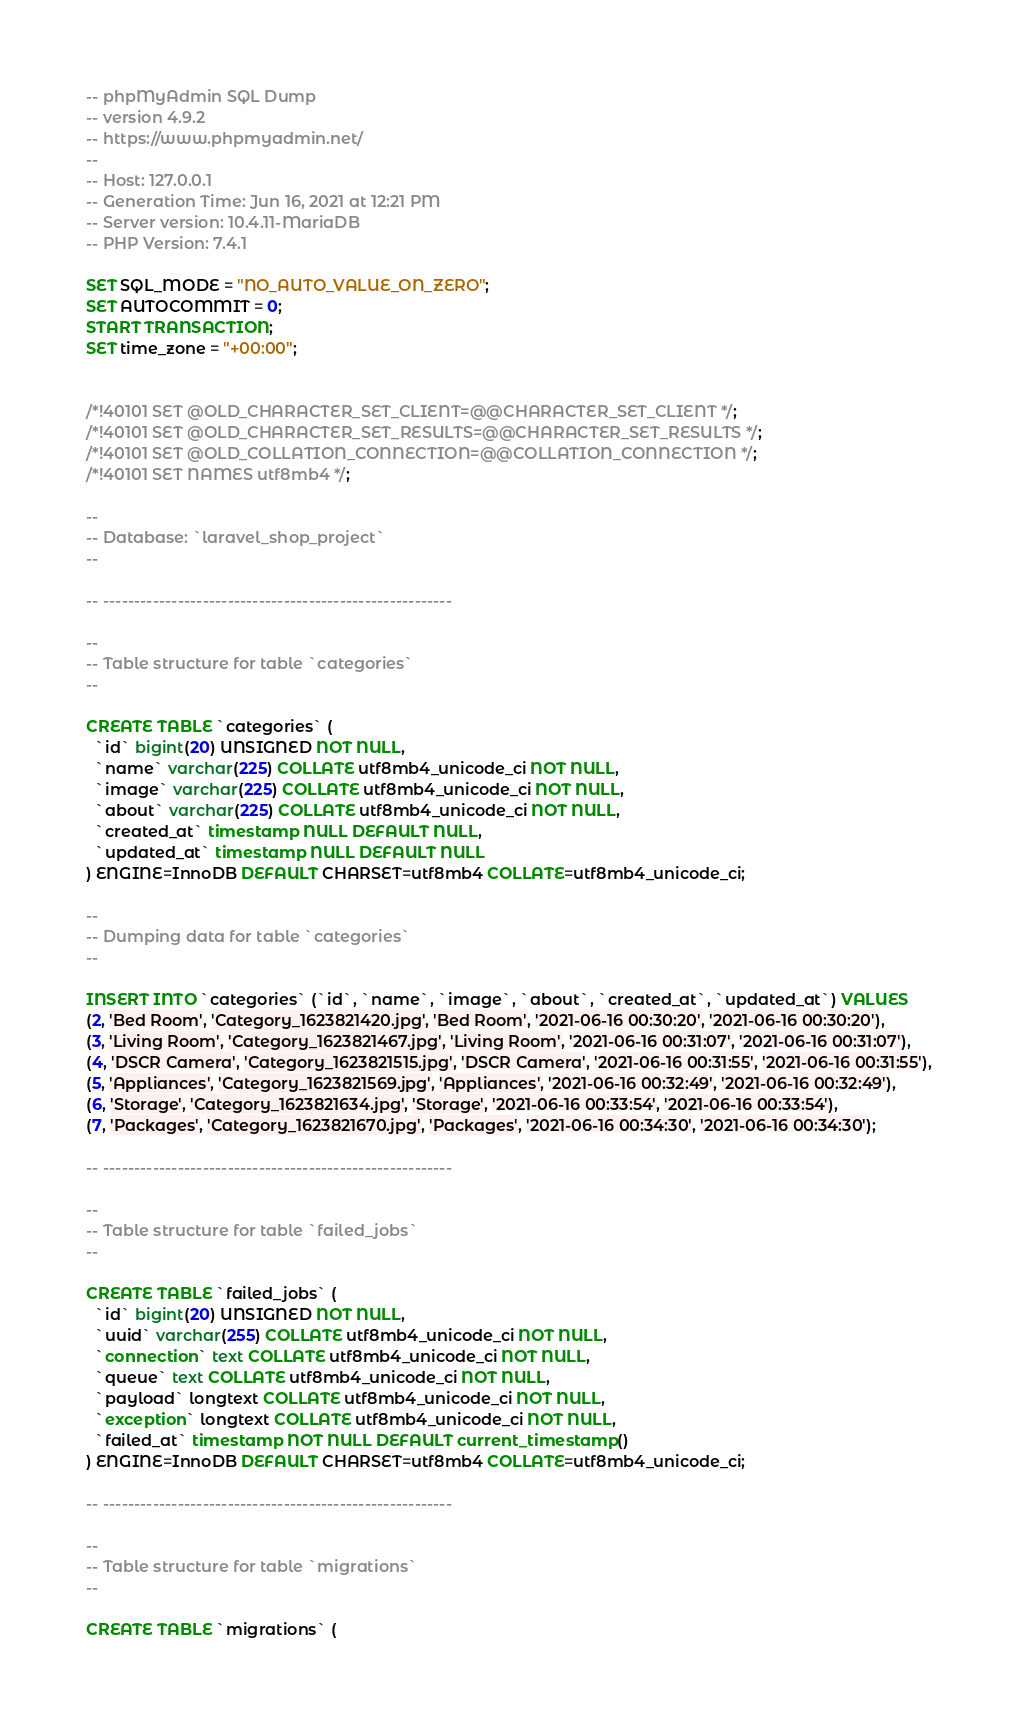Convert code to text. <code><loc_0><loc_0><loc_500><loc_500><_SQL_>-- phpMyAdmin SQL Dump
-- version 4.9.2
-- https://www.phpmyadmin.net/
--
-- Host: 127.0.0.1
-- Generation Time: Jun 16, 2021 at 12:21 PM
-- Server version: 10.4.11-MariaDB
-- PHP Version: 7.4.1

SET SQL_MODE = "NO_AUTO_VALUE_ON_ZERO";
SET AUTOCOMMIT = 0;
START TRANSACTION;
SET time_zone = "+00:00";


/*!40101 SET @OLD_CHARACTER_SET_CLIENT=@@CHARACTER_SET_CLIENT */;
/*!40101 SET @OLD_CHARACTER_SET_RESULTS=@@CHARACTER_SET_RESULTS */;
/*!40101 SET @OLD_COLLATION_CONNECTION=@@COLLATION_CONNECTION */;
/*!40101 SET NAMES utf8mb4 */;

--
-- Database: `laravel_shop_project`
--

-- --------------------------------------------------------

--
-- Table structure for table `categories`
--

CREATE TABLE `categories` (
  `id` bigint(20) UNSIGNED NOT NULL,
  `name` varchar(225) COLLATE utf8mb4_unicode_ci NOT NULL,
  `image` varchar(225) COLLATE utf8mb4_unicode_ci NOT NULL,
  `about` varchar(225) COLLATE utf8mb4_unicode_ci NOT NULL,
  `created_at` timestamp NULL DEFAULT NULL,
  `updated_at` timestamp NULL DEFAULT NULL
) ENGINE=InnoDB DEFAULT CHARSET=utf8mb4 COLLATE=utf8mb4_unicode_ci;

--
-- Dumping data for table `categories`
--

INSERT INTO `categories` (`id`, `name`, `image`, `about`, `created_at`, `updated_at`) VALUES
(2, 'Bed Room', 'Category_1623821420.jpg', 'Bed Room', '2021-06-16 00:30:20', '2021-06-16 00:30:20'),
(3, 'Living Room', 'Category_1623821467.jpg', 'Living Room', '2021-06-16 00:31:07', '2021-06-16 00:31:07'),
(4, 'DSCR Camera', 'Category_1623821515.jpg', 'DSCR Camera', '2021-06-16 00:31:55', '2021-06-16 00:31:55'),
(5, 'Appliances', 'Category_1623821569.jpg', 'Appliances', '2021-06-16 00:32:49', '2021-06-16 00:32:49'),
(6, 'Storage', 'Category_1623821634.jpg', 'Storage', '2021-06-16 00:33:54', '2021-06-16 00:33:54'),
(7, 'Packages', 'Category_1623821670.jpg', 'Packages', '2021-06-16 00:34:30', '2021-06-16 00:34:30');

-- --------------------------------------------------------

--
-- Table structure for table `failed_jobs`
--

CREATE TABLE `failed_jobs` (
  `id` bigint(20) UNSIGNED NOT NULL,
  `uuid` varchar(255) COLLATE utf8mb4_unicode_ci NOT NULL,
  `connection` text COLLATE utf8mb4_unicode_ci NOT NULL,
  `queue` text COLLATE utf8mb4_unicode_ci NOT NULL,
  `payload` longtext COLLATE utf8mb4_unicode_ci NOT NULL,
  `exception` longtext COLLATE utf8mb4_unicode_ci NOT NULL,
  `failed_at` timestamp NOT NULL DEFAULT current_timestamp()
) ENGINE=InnoDB DEFAULT CHARSET=utf8mb4 COLLATE=utf8mb4_unicode_ci;

-- --------------------------------------------------------

--
-- Table structure for table `migrations`
--

CREATE TABLE `migrations` (</code> 